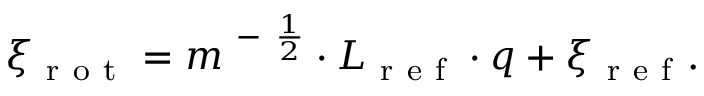Convert formula to latex. <formula><loc_0><loc_0><loc_500><loc_500>\xi _ { r o t } = m ^ { - \frac { 1 } { 2 } } \cdot L _ { r e f } \cdot q + \xi _ { r e f } .</formula> 